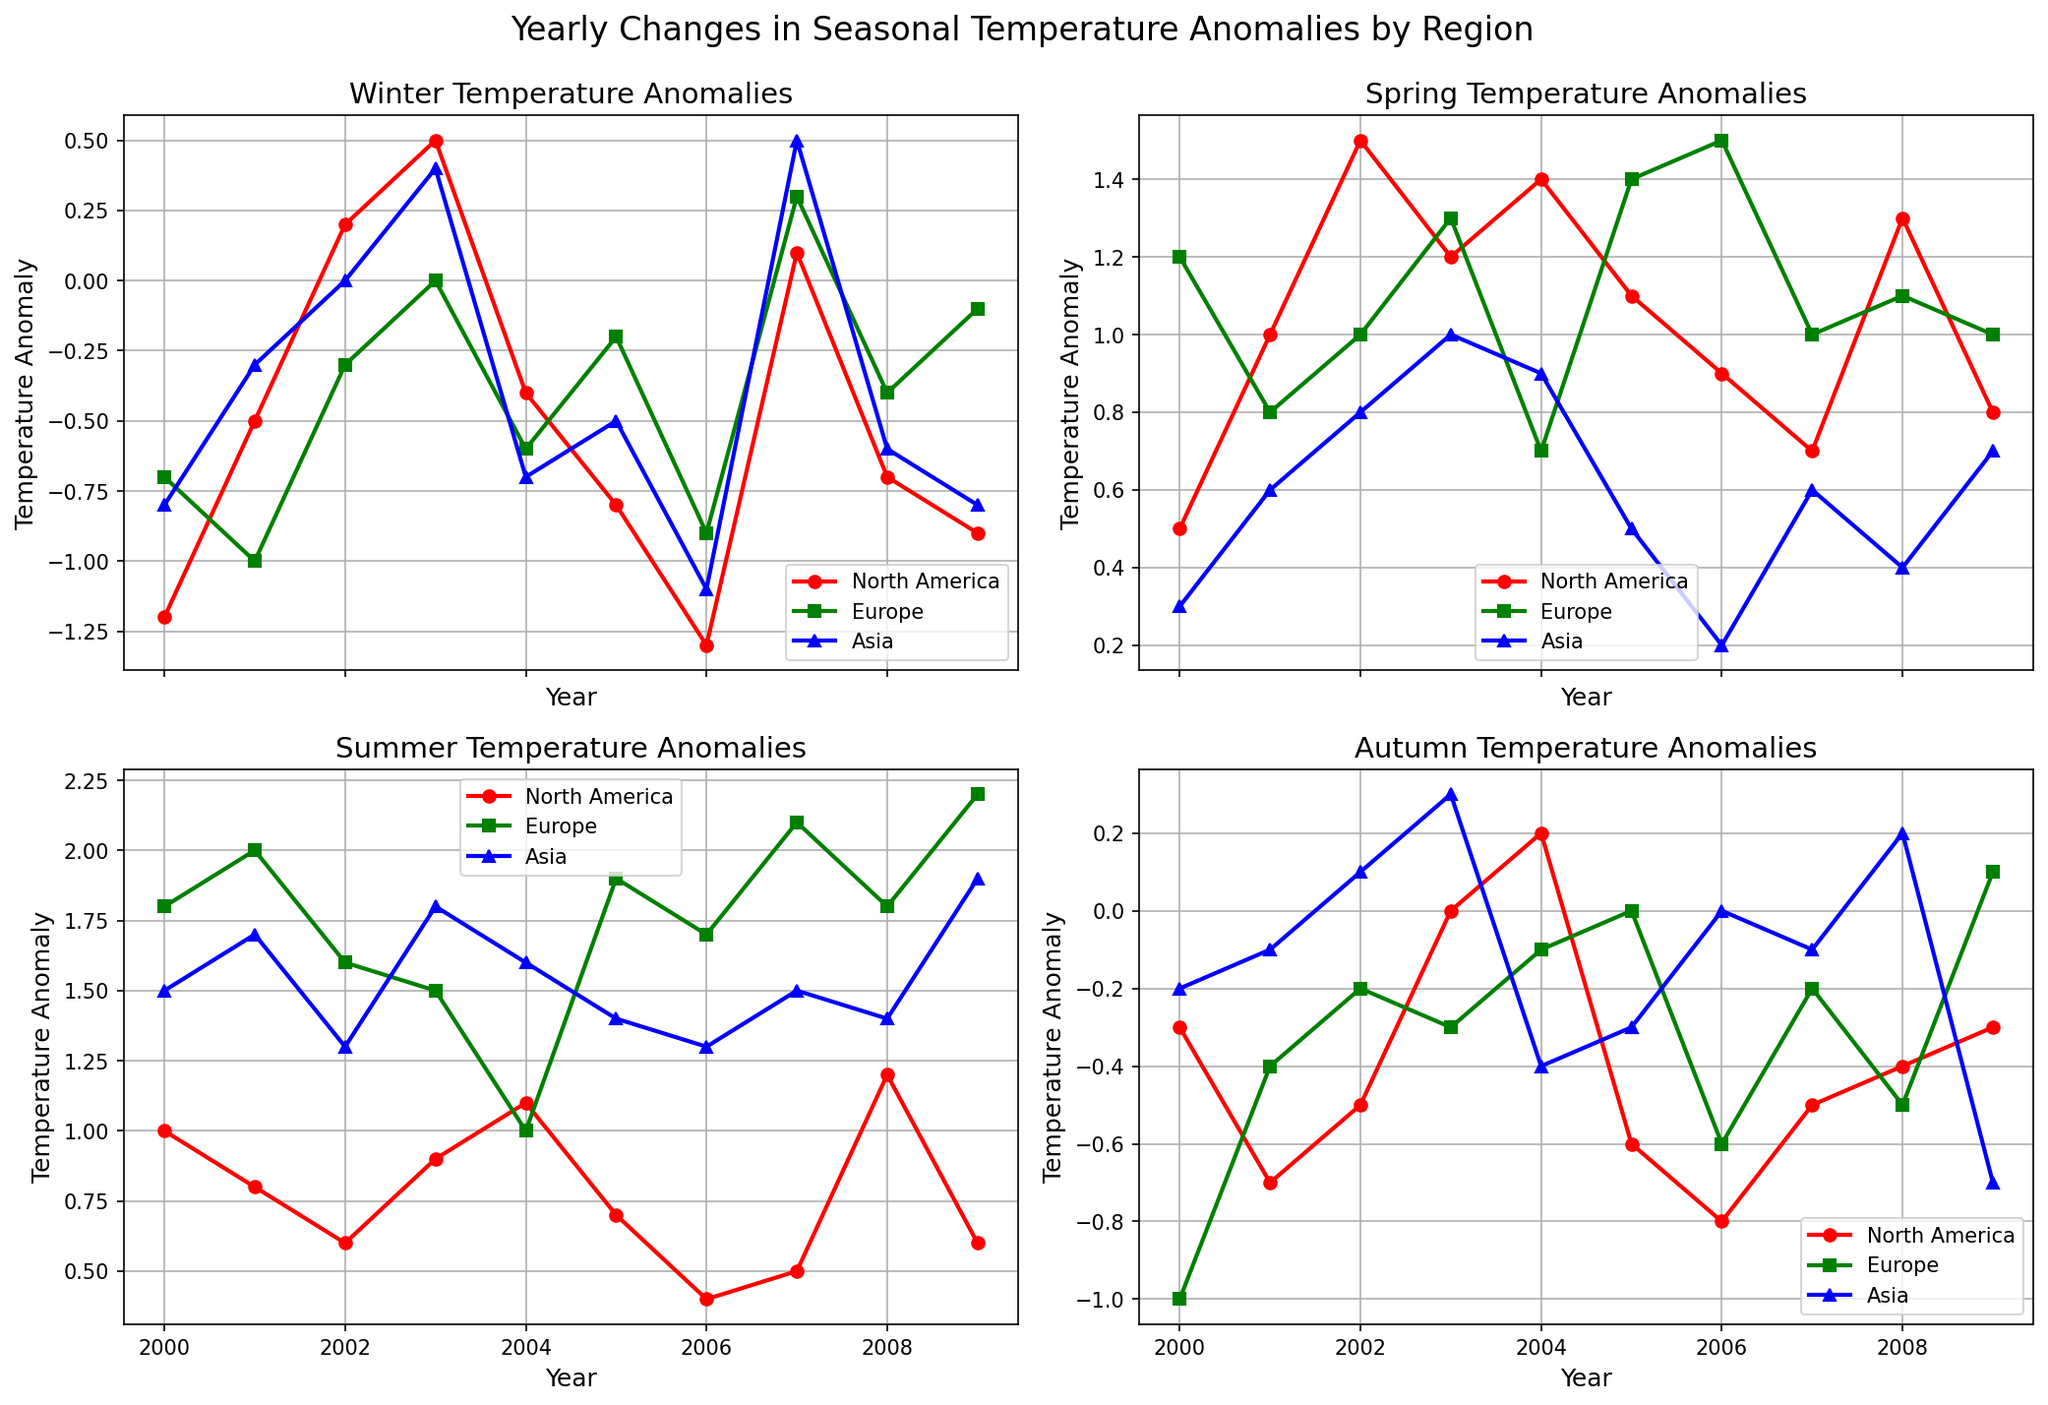What year had the lowest Winter temperature anomaly in North America? To find the year with the lowest Winter temperature anomaly in North America, look at the Winter plot and identify the lowest point for North America's (red line with circles). The lowest point corresponds to the year 2006.
Answer: 2006 Which region had the highest Spring temperature anomaly in 2007? To identify the region with the highest Spring temperature anomaly in 2007, refer to the Spring plot and compare the heights of the markers in 2007. Europe (green line with squares) is the highest.
Answer: Europe How did the Summer temperature anomalies in Europe and Asia compare in 2005? Look at the Summer plot for the year 2005 and compare the positions of Europe (blue line with triangles) and Asia (yellow line with diamonds). Europe is higher than Asia.
Answer: Europe is higher During which season in 2003 did North America have a positive temperature anomaly, and how much was it? Identify the positive anomalies for North America (red line with circles) in 2003 across all four seasonal plots. In Autumn, North America has a positive anomaly of 0.0, meaning it is neutral. Spring also shows a positive anomaly. In Spring, the anomaly is 1.2.
Answer: Spring, 1.2 What is the average Summer temperature anomaly for Europe from 2000 to 2009? Calculate the average by summing up the Summer anomalies for Europe (blue line with triangles) across the years (1.8 + 2.0 + 1.6 + 1.5 + 1.0 + 1.9 + 1.7 + 2.1 + 1.8 + 2.2), total is 17.6, and divide by the number of years (10).
Answer: 1.76 How did Asia's Autumn temperature anomaly change from 2007 to 2008? Observe the Autumn plot and track the yellow line with diamonds representing Asia. The value in 2007 is -0.1, and in 2008 it is 0.2. The change is 0.2 - (-0.1) = 0.3.
Answer: Increased by 0.3 Which season experienced the most negative anomaly in any region for the entire data set? Review all the plots and identify the most negative anomaly point. North America's Winter of 2006 shows the lowest with -1.3.
Answer: Winter, North America, 2006 What is the difference between the Winter temperature anomalies of North America and Europe in 2001? Note the Winter temperatures in 2001 for both North America (-0.5, red line with circles) and Europe (-1.0, blue line with triangles). The difference is -0.5 - (-1.0) = 0.5.
Answer: 0.5 In which year did Asia have the highest Summer temperature anomaly and what was the value? Observe the Summer plot and track the yellow line with diamonds for Asia. The highest value occurs in 2003 with 1.8 as the anomaly.
Answer: 2003, 1.8 